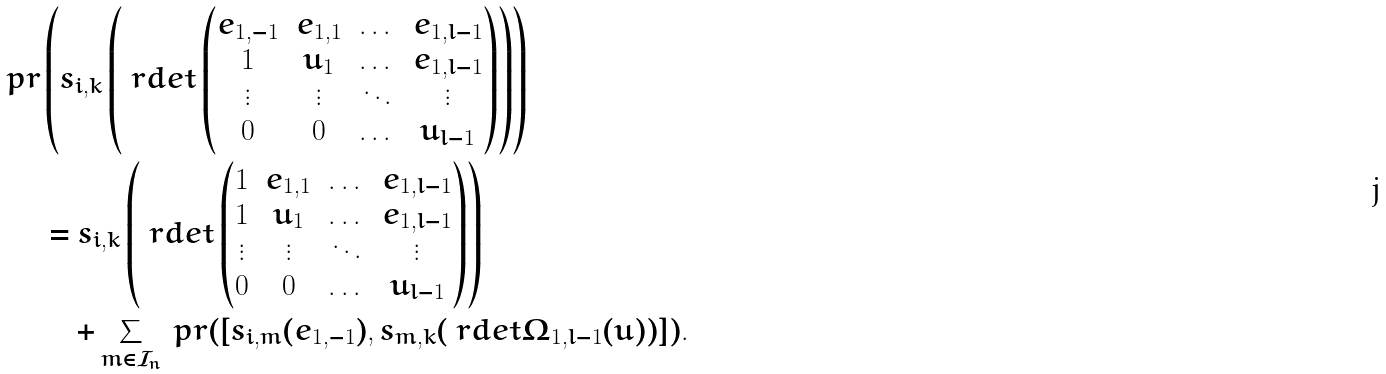Convert formula to latex. <formula><loc_0><loc_0><loc_500><loc_500>\ p r & \left ( s _ { i , k } \left ( \ r d e t \begin{pmatrix} e _ { 1 , - 1 } & e _ { 1 , 1 } & \dots & e _ { 1 , l - 1 } \\ 1 & u _ { 1 } & \dots & e _ { 1 , l - 1 } \\ \vdots & \vdots & \ddots & \vdots \\ 0 & 0 & \dots & u _ { l - 1 } \end{pmatrix} \right ) \right ) \\ & = s _ { i , k } \left ( \ r d e t \begin{pmatrix} 1 & e _ { 1 , 1 } & \dots & e _ { 1 , l - 1 } \\ 1 & u _ { 1 } & \dots & e _ { 1 , l - 1 } \\ \vdots & \vdots & \ddots & \vdots \\ 0 & 0 & \dots & u _ { l - 1 } \end{pmatrix} \right ) \\ & \quad + \sum _ { m \in \mathcal { I } _ { n } } \ p r ( [ s _ { i , m } ( e _ { 1 , - 1 } ) , s _ { m , k } ( \ r d e t \Omega _ { 1 , l - 1 } ( u ) ) ] ) .</formula> 